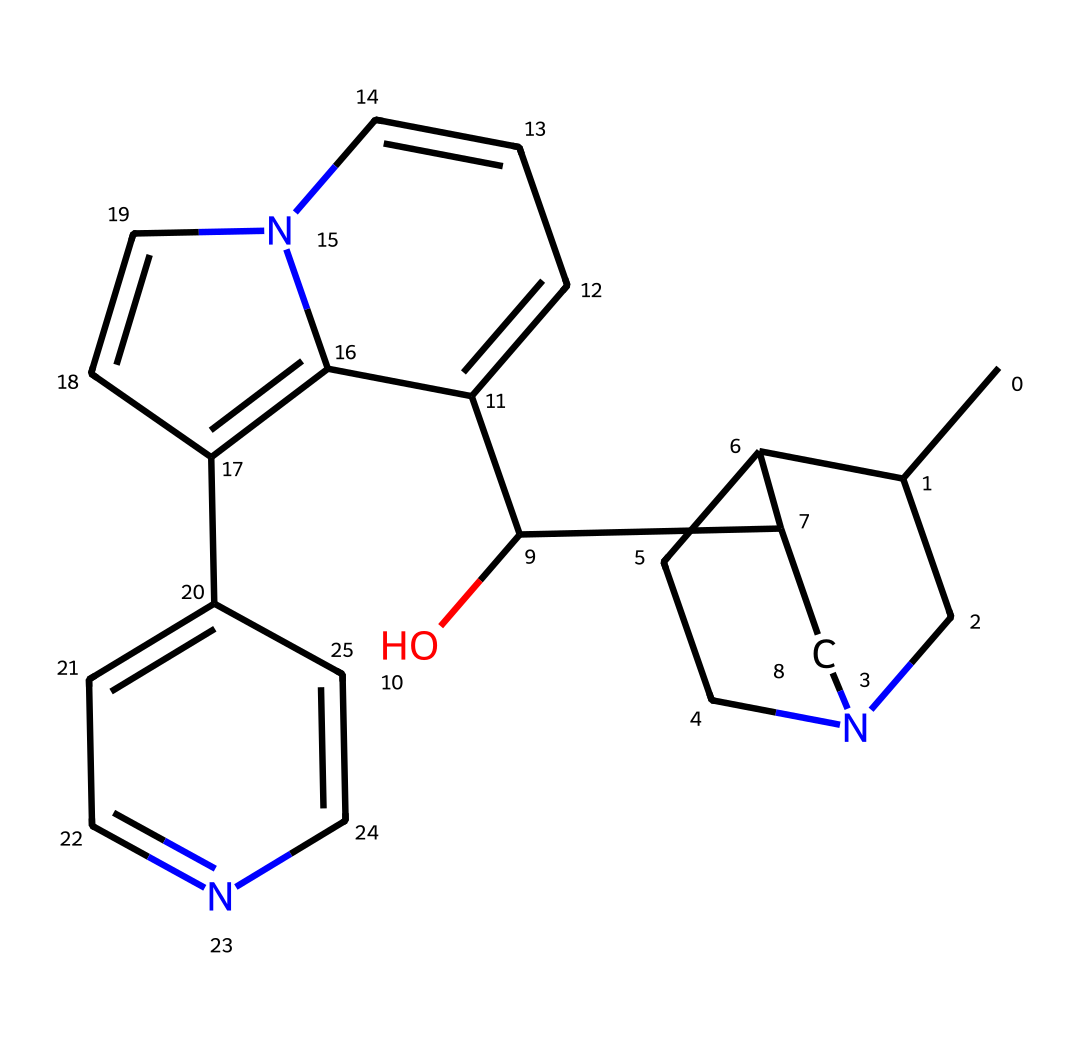What is the molecular formula of quinine? To determine the molecular formula, count the number of carbon, hydrogen, nitrogen, and oxygen atoms in the SMILES representation. There are 20 carbon atoms, 24 hydrogen atoms, 2 nitrogen atoms, and 1 oxygen atom. Therefore, the molecular formula is C20H24N2O.
Answer: C20H24N2O How many rings are present in the structure of quinine? Examining the SMILES representation shows the presence of multiple cyclic structures. By identifying the numerical indicators (like 1, 2, etc.), we can find that there are 4 rings in total within the structure of quinine.
Answer: 4 What is the key functional group in quinine? The structure reveals the presence of a hydroxyl group (-OH) and nitrogen atoms. The presence of a hydroxyl group classifies it as containing alcohol functionality, which is a key functional group associated with the solubility and reactivity of quinine.
Answer: hydroxyl group Which atoms are responsible for the bitter taste of quinine? The nitrogen atoms present in the structure of quinine are indicative of the alkaloid class, which is well-known for having a bitter taste. Alkaloids often exert their flavor properties through their nitrogen-containing structures.
Answer: nitrogen atoms How many nitrogen atoms are in the chemical structure of quinine? Counting the nitrogen atoms as represented in the SMILES indicates that there are 2 nitrogen atoms present in the quinine structure.
Answer: 2 Is quinine a natural product or synthetic compound? Quinine is derived from the bark of the cinchona tree, making it a natural product. This classification comes from its historical use and origin in nature.
Answer: natural product 